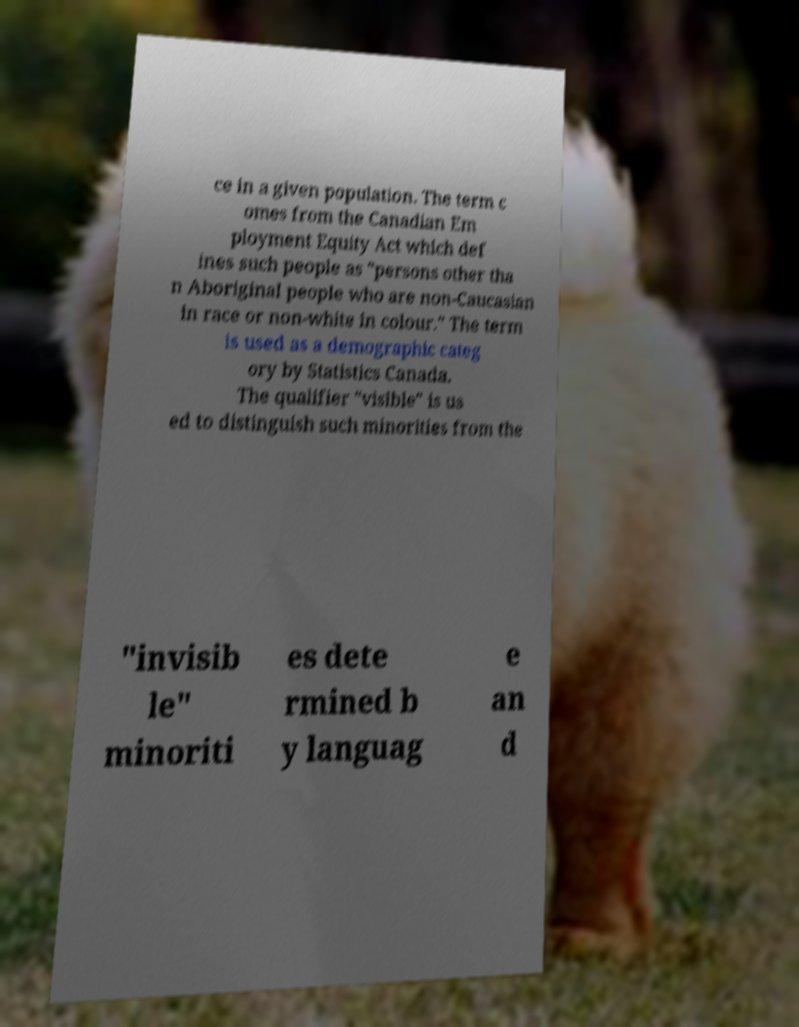There's text embedded in this image that I need extracted. Can you transcribe it verbatim? ce in a given population. The term c omes from the Canadian Em ployment Equity Act which def ines such people as "persons other tha n Aboriginal people who are non-Caucasian in race or non-white in colour." The term is used as a demographic categ ory by Statistics Canada. The qualifier "visible" is us ed to distinguish such minorities from the "invisib le" minoriti es dete rmined b y languag e an d 